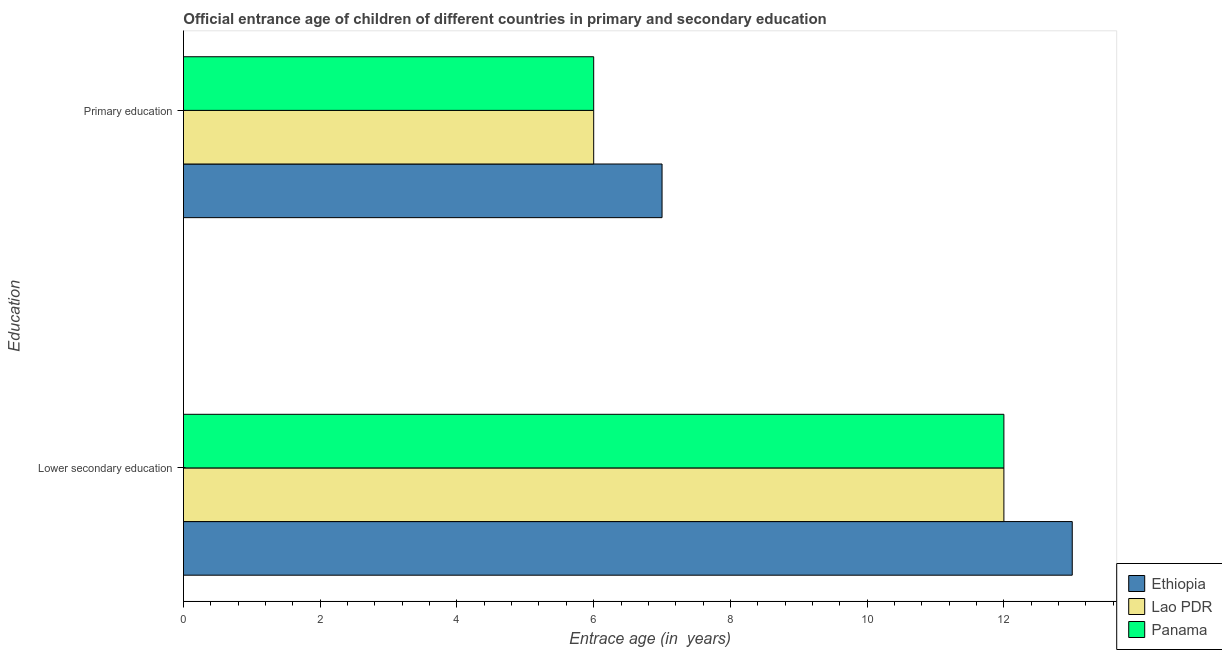How many different coloured bars are there?
Your answer should be very brief. 3. How many groups of bars are there?
Offer a very short reply. 2. How many bars are there on the 2nd tick from the bottom?
Offer a terse response. 3. What is the label of the 1st group of bars from the top?
Provide a short and direct response. Primary education. What is the entrance age of children in lower secondary education in Panama?
Give a very brief answer. 12. Across all countries, what is the maximum entrance age of children in lower secondary education?
Provide a succinct answer. 13. Across all countries, what is the minimum entrance age of children in lower secondary education?
Keep it short and to the point. 12. In which country was the entrance age of children in lower secondary education maximum?
Ensure brevity in your answer.  Ethiopia. In which country was the entrance age of children in lower secondary education minimum?
Keep it short and to the point. Lao PDR. What is the total entrance age of children in lower secondary education in the graph?
Provide a succinct answer. 37. What is the difference between the entrance age of children in lower secondary education in Lao PDR and that in Ethiopia?
Ensure brevity in your answer.  -1. What is the difference between the entrance age of chiildren in primary education in Ethiopia and the entrance age of children in lower secondary education in Lao PDR?
Give a very brief answer. -5. What is the average entrance age of chiildren in primary education per country?
Give a very brief answer. 6.33. What is the difference between the entrance age of children in lower secondary education and entrance age of chiildren in primary education in Panama?
Offer a terse response. 6. What is the ratio of the entrance age of children in lower secondary education in Lao PDR to that in Ethiopia?
Offer a terse response. 0.92. Is the entrance age of children in lower secondary education in Panama less than that in Lao PDR?
Your response must be concise. No. What does the 2nd bar from the top in Lower secondary education represents?
Offer a terse response. Lao PDR. What does the 3rd bar from the bottom in Lower secondary education represents?
Offer a very short reply. Panama. How many bars are there?
Provide a short and direct response. 6. Are all the bars in the graph horizontal?
Provide a succinct answer. Yes. How many countries are there in the graph?
Your answer should be very brief. 3. Are the values on the major ticks of X-axis written in scientific E-notation?
Your answer should be very brief. No. Does the graph contain any zero values?
Provide a short and direct response. No. What is the title of the graph?
Provide a succinct answer. Official entrance age of children of different countries in primary and secondary education. What is the label or title of the X-axis?
Ensure brevity in your answer.  Entrace age (in  years). What is the label or title of the Y-axis?
Provide a short and direct response. Education. What is the Entrace age (in  years) of Lao PDR in Lower secondary education?
Provide a succinct answer. 12. What is the Entrace age (in  years) in Panama in Lower secondary education?
Provide a succinct answer. 12. What is the Entrace age (in  years) in Panama in Primary education?
Offer a terse response. 6. Across all Education, what is the maximum Entrace age (in  years) in Ethiopia?
Provide a succinct answer. 13. Across all Education, what is the maximum Entrace age (in  years) in Lao PDR?
Give a very brief answer. 12. Across all Education, what is the maximum Entrace age (in  years) of Panama?
Your answer should be compact. 12. Across all Education, what is the minimum Entrace age (in  years) in Ethiopia?
Keep it short and to the point. 7. What is the total Entrace age (in  years) of Panama in the graph?
Give a very brief answer. 18. What is the difference between the Entrace age (in  years) of Lao PDR in Lower secondary education and that in Primary education?
Your answer should be very brief. 6. What is the difference between the Entrace age (in  years) in Ethiopia in Lower secondary education and the Entrace age (in  years) in Lao PDR in Primary education?
Make the answer very short. 7. What is the difference between the Entrace age (in  years) of Ethiopia in Lower secondary education and the Entrace age (in  years) of Panama in Primary education?
Provide a short and direct response. 7. What is the difference between the Entrace age (in  years) in Lao PDR in Lower secondary education and the Entrace age (in  years) in Panama in Primary education?
Make the answer very short. 6. What is the average Entrace age (in  years) in Lao PDR per Education?
Give a very brief answer. 9. What is the difference between the Entrace age (in  years) in Lao PDR and Entrace age (in  years) in Panama in Primary education?
Offer a terse response. 0. What is the ratio of the Entrace age (in  years) of Ethiopia in Lower secondary education to that in Primary education?
Keep it short and to the point. 1.86. What is the difference between the highest and the second highest Entrace age (in  years) of Panama?
Offer a terse response. 6. What is the difference between the highest and the lowest Entrace age (in  years) in Panama?
Give a very brief answer. 6. 